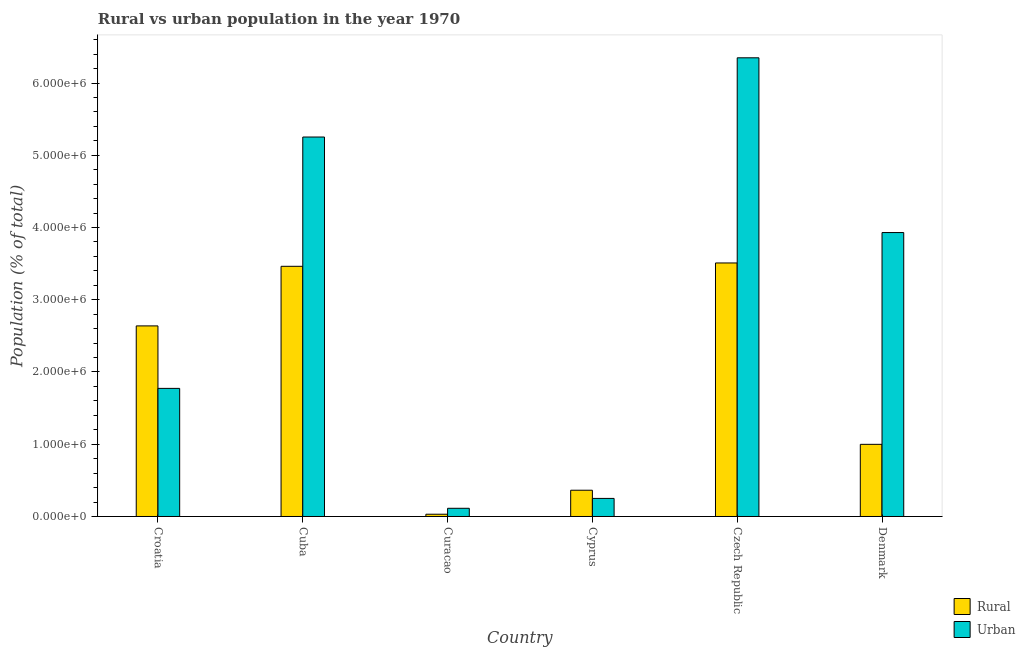How many different coloured bars are there?
Your answer should be very brief. 2. Are the number of bars on each tick of the X-axis equal?
Provide a short and direct response. Yes. How many bars are there on the 1st tick from the left?
Provide a succinct answer. 2. What is the label of the 5th group of bars from the left?
Provide a short and direct response. Czech Republic. What is the rural population density in Croatia?
Make the answer very short. 2.64e+06. Across all countries, what is the maximum rural population density?
Your answer should be compact. 3.51e+06. Across all countries, what is the minimum rural population density?
Keep it short and to the point. 3.12e+04. In which country was the rural population density maximum?
Give a very brief answer. Czech Republic. In which country was the urban population density minimum?
Provide a short and direct response. Curacao. What is the total urban population density in the graph?
Your response must be concise. 1.77e+07. What is the difference between the rural population density in Cyprus and that in Czech Republic?
Provide a succinct answer. -3.15e+06. What is the difference between the rural population density in Cyprus and the urban population density in Curacao?
Make the answer very short. 2.50e+05. What is the average urban population density per country?
Ensure brevity in your answer.  2.94e+06. What is the difference between the urban population density and rural population density in Denmark?
Offer a very short reply. 2.93e+06. What is the ratio of the urban population density in Croatia to that in Denmark?
Your answer should be compact. 0.45. Is the urban population density in Cuba less than that in Denmark?
Ensure brevity in your answer.  No. What is the difference between the highest and the second highest rural population density?
Your response must be concise. 4.64e+04. What is the difference between the highest and the lowest rural population density?
Provide a succinct answer. 3.48e+06. In how many countries, is the urban population density greater than the average urban population density taken over all countries?
Your response must be concise. 3. Is the sum of the rural population density in Curacao and Cyprus greater than the maximum urban population density across all countries?
Provide a succinct answer. No. What does the 1st bar from the left in Denmark represents?
Provide a succinct answer. Rural. What does the 1st bar from the right in Denmark represents?
Provide a short and direct response. Urban. How many bars are there?
Your answer should be very brief. 12. Are all the bars in the graph horizontal?
Keep it short and to the point. No. What is the difference between two consecutive major ticks on the Y-axis?
Make the answer very short. 1.00e+06. Are the values on the major ticks of Y-axis written in scientific E-notation?
Your response must be concise. Yes. Does the graph contain grids?
Offer a terse response. No. How many legend labels are there?
Offer a very short reply. 2. How are the legend labels stacked?
Ensure brevity in your answer.  Vertical. What is the title of the graph?
Your response must be concise. Rural vs urban population in the year 1970. What is the label or title of the X-axis?
Give a very brief answer. Country. What is the label or title of the Y-axis?
Your answer should be very brief. Population (% of total). What is the Population (% of total) of Rural in Croatia?
Your response must be concise. 2.64e+06. What is the Population (% of total) of Urban in Croatia?
Ensure brevity in your answer.  1.77e+06. What is the Population (% of total) of Rural in Cuba?
Provide a short and direct response. 3.46e+06. What is the Population (% of total) in Urban in Cuba?
Make the answer very short. 5.25e+06. What is the Population (% of total) in Rural in Curacao?
Offer a terse response. 3.12e+04. What is the Population (% of total) of Urban in Curacao?
Provide a succinct answer. 1.14e+05. What is the Population (% of total) of Rural in Cyprus?
Offer a terse response. 3.64e+05. What is the Population (% of total) of Urban in Cyprus?
Give a very brief answer. 2.50e+05. What is the Population (% of total) of Rural in Czech Republic?
Your answer should be very brief. 3.51e+06. What is the Population (% of total) of Urban in Czech Republic?
Your answer should be compact. 6.35e+06. What is the Population (% of total) of Rural in Denmark?
Your answer should be compact. 9.99e+05. What is the Population (% of total) of Urban in Denmark?
Ensure brevity in your answer.  3.93e+06. Across all countries, what is the maximum Population (% of total) in Rural?
Keep it short and to the point. 3.51e+06. Across all countries, what is the maximum Population (% of total) of Urban?
Offer a terse response. 6.35e+06. Across all countries, what is the minimum Population (% of total) of Rural?
Provide a succinct answer. 3.12e+04. Across all countries, what is the minimum Population (% of total) in Urban?
Provide a short and direct response. 1.14e+05. What is the total Population (% of total) of Rural in the graph?
Ensure brevity in your answer.  1.10e+07. What is the total Population (% of total) in Urban in the graph?
Your answer should be compact. 1.77e+07. What is the difference between the Population (% of total) in Rural in Croatia and that in Cuba?
Offer a terse response. -8.25e+05. What is the difference between the Population (% of total) in Urban in Croatia and that in Cuba?
Offer a very short reply. -3.48e+06. What is the difference between the Population (% of total) in Rural in Croatia and that in Curacao?
Give a very brief answer. 2.61e+06. What is the difference between the Population (% of total) of Urban in Croatia and that in Curacao?
Give a very brief answer. 1.66e+06. What is the difference between the Population (% of total) in Rural in Croatia and that in Cyprus?
Provide a short and direct response. 2.27e+06. What is the difference between the Population (% of total) in Urban in Croatia and that in Cyprus?
Ensure brevity in your answer.  1.52e+06. What is the difference between the Population (% of total) of Rural in Croatia and that in Czech Republic?
Keep it short and to the point. -8.71e+05. What is the difference between the Population (% of total) in Urban in Croatia and that in Czech Republic?
Give a very brief answer. -4.58e+06. What is the difference between the Population (% of total) in Rural in Croatia and that in Denmark?
Your answer should be compact. 1.64e+06. What is the difference between the Population (% of total) of Urban in Croatia and that in Denmark?
Ensure brevity in your answer.  -2.16e+06. What is the difference between the Population (% of total) in Rural in Cuba and that in Curacao?
Give a very brief answer. 3.43e+06. What is the difference between the Population (% of total) of Urban in Cuba and that in Curacao?
Offer a very short reply. 5.14e+06. What is the difference between the Population (% of total) in Rural in Cuba and that in Cyprus?
Make the answer very short. 3.10e+06. What is the difference between the Population (% of total) in Urban in Cuba and that in Cyprus?
Offer a very short reply. 5.00e+06. What is the difference between the Population (% of total) of Rural in Cuba and that in Czech Republic?
Give a very brief answer. -4.64e+04. What is the difference between the Population (% of total) in Urban in Cuba and that in Czech Republic?
Offer a very short reply. -1.10e+06. What is the difference between the Population (% of total) of Rural in Cuba and that in Denmark?
Offer a very short reply. 2.46e+06. What is the difference between the Population (% of total) of Urban in Cuba and that in Denmark?
Ensure brevity in your answer.  1.32e+06. What is the difference between the Population (% of total) in Rural in Curacao and that in Cyprus?
Your answer should be very brief. -3.32e+05. What is the difference between the Population (% of total) in Urban in Curacao and that in Cyprus?
Your response must be concise. -1.37e+05. What is the difference between the Population (% of total) of Rural in Curacao and that in Czech Republic?
Provide a succinct answer. -3.48e+06. What is the difference between the Population (% of total) in Urban in Curacao and that in Czech Republic?
Ensure brevity in your answer.  -6.24e+06. What is the difference between the Population (% of total) of Rural in Curacao and that in Denmark?
Give a very brief answer. -9.68e+05. What is the difference between the Population (% of total) in Urban in Curacao and that in Denmark?
Ensure brevity in your answer.  -3.82e+06. What is the difference between the Population (% of total) in Rural in Cyprus and that in Czech Republic?
Give a very brief answer. -3.15e+06. What is the difference between the Population (% of total) of Urban in Cyprus and that in Czech Republic?
Your answer should be very brief. -6.10e+06. What is the difference between the Population (% of total) of Rural in Cyprus and that in Denmark?
Offer a terse response. -6.35e+05. What is the difference between the Population (% of total) in Urban in Cyprus and that in Denmark?
Make the answer very short. -3.68e+06. What is the difference between the Population (% of total) in Rural in Czech Republic and that in Denmark?
Provide a short and direct response. 2.51e+06. What is the difference between the Population (% of total) of Urban in Czech Republic and that in Denmark?
Your answer should be compact. 2.42e+06. What is the difference between the Population (% of total) in Rural in Croatia and the Population (% of total) in Urban in Cuba?
Keep it short and to the point. -2.61e+06. What is the difference between the Population (% of total) of Rural in Croatia and the Population (% of total) of Urban in Curacao?
Ensure brevity in your answer.  2.52e+06. What is the difference between the Population (% of total) in Rural in Croatia and the Population (% of total) in Urban in Cyprus?
Make the answer very short. 2.39e+06. What is the difference between the Population (% of total) in Rural in Croatia and the Population (% of total) in Urban in Czech Republic?
Your answer should be very brief. -3.71e+06. What is the difference between the Population (% of total) of Rural in Croatia and the Population (% of total) of Urban in Denmark?
Your answer should be compact. -1.29e+06. What is the difference between the Population (% of total) in Rural in Cuba and the Population (% of total) in Urban in Curacao?
Keep it short and to the point. 3.35e+06. What is the difference between the Population (% of total) in Rural in Cuba and the Population (% of total) in Urban in Cyprus?
Keep it short and to the point. 3.21e+06. What is the difference between the Population (% of total) of Rural in Cuba and the Population (% of total) of Urban in Czech Republic?
Offer a very short reply. -2.89e+06. What is the difference between the Population (% of total) of Rural in Cuba and the Population (% of total) of Urban in Denmark?
Your response must be concise. -4.67e+05. What is the difference between the Population (% of total) in Rural in Curacao and the Population (% of total) in Urban in Cyprus?
Provide a short and direct response. -2.19e+05. What is the difference between the Population (% of total) in Rural in Curacao and the Population (% of total) in Urban in Czech Republic?
Your answer should be compact. -6.32e+06. What is the difference between the Population (% of total) of Rural in Curacao and the Population (% of total) of Urban in Denmark?
Give a very brief answer. -3.90e+06. What is the difference between the Population (% of total) in Rural in Cyprus and the Population (% of total) in Urban in Czech Republic?
Offer a terse response. -5.99e+06. What is the difference between the Population (% of total) of Rural in Cyprus and the Population (% of total) of Urban in Denmark?
Your response must be concise. -3.57e+06. What is the difference between the Population (% of total) in Rural in Czech Republic and the Population (% of total) in Urban in Denmark?
Your answer should be very brief. -4.21e+05. What is the average Population (% of total) of Rural per country?
Give a very brief answer. 1.83e+06. What is the average Population (% of total) in Urban per country?
Your response must be concise. 2.94e+06. What is the difference between the Population (% of total) of Rural and Population (% of total) of Urban in Croatia?
Your response must be concise. 8.65e+05. What is the difference between the Population (% of total) in Rural and Population (% of total) in Urban in Cuba?
Offer a very short reply. -1.79e+06. What is the difference between the Population (% of total) in Rural and Population (% of total) in Urban in Curacao?
Offer a terse response. -8.24e+04. What is the difference between the Population (% of total) of Rural and Population (% of total) of Urban in Cyprus?
Provide a short and direct response. 1.13e+05. What is the difference between the Population (% of total) in Rural and Population (% of total) in Urban in Czech Republic?
Ensure brevity in your answer.  -2.84e+06. What is the difference between the Population (% of total) in Rural and Population (% of total) in Urban in Denmark?
Give a very brief answer. -2.93e+06. What is the ratio of the Population (% of total) of Rural in Croatia to that in Cuba?
Provide a succinct answer. 0.76. What is the ratio of the Population (% of total) of Urban in Croatia to that in Cuba?
Ensure brevity in your answer.  0.34. What is the ratio of the Population (% of total) of Rural in Croatia to that in Curacao?
Offer a terse response. 84.57. What is the ratio of the Population (% of total) of Urban in Croatia to that in Curacao?
Ensure brevity in your answer.  15.62. What is the ratio of the Population (% of total) of Rural in Croatia to that in Cyprus?
Ensure brevity in your answer.  7.26. What is the ratio of the Population (% of total) in Urban in Croatia to that in Cyprus?
Make the answer very short. 7.09. What is the ratio of the Population (% of total) in Rural in Croatia to that in Czech Republic?
Make the answer very short. 0.75. What is the ratio of the Population (% of total) of Urban in Croatia to that in Czech Republic?
Your response must be concise. 0.28. What is the ratio of the Population (% of total) of Rural in Croatia to that in Denmark?
Offer a very short reply. 2.64. What is the ratio of the Population (% of total) of Urban in Croatia to that in Denmark?
Your answer should be very brief. 0.45. What is the ratio of the Population (% of total) of Rural in Cuba to that in Curacao?
Offer a terse response. 111.01. What is the ratio of the Population (% of total) in Urban in Cuba to that in Curacao?
Offer a terse response. 46.26. What is the ratio of the Population (% of total) in Rural in Cuba to that in Cyprus?
Keep it short and to the point. 9.53. What is the ratio of the Population (% of total) in Urban in Cuba to that in Cyprus?
Keep it short and to the point. 21. What is the ratio of the Population (% of total) of Rural in Cuba to that in Czech Republic?
Offer a very short reply. 0.99. What is the ratio of the Population (% of total) of Urban in Cuba to that in Czech Republic?
Provide a short and direct response. 0.83. What is the ratio of the Population (% of total) in Rural in Cuba to that in Denmark?
Keep it short and to the point. 3.47. What is the ratio of the Population (% of total) in Urban in Cuba to that in Denmark?
Your answer should be compact. 1.34. What is the ratio of the Population (% of total) of Rural in Curacao to that in Cyprus?
Give a very brief answer. 0.09. What is the ratio of the Population (% of total) of Urban in Curacao to that in Cyprus?
Your response must be concise. 0.45. What is the ratio of the Population (% of total) in Rural in Curacao to that in Czech Republic?
Make the answer very short. 0.01. What is the ratio of the Population (% of total) in Urban in Curacao to that in Czech Republic?
Offer a very short reply. 0.02. What is the ratio of the Population (% of total) in Rural in Curacao to that in Denmark?
Your response must be concise. 0.03. What is the ratio of the Population (% of total) in Urban in Curacao to that in Denmark?
Make the answer very short. 0.03. What is the ratio of the Population (% of total) of Rural in Cyprus to that in Czech Republic?
Provide a short and direct response. 0.1. What is the ratio of the Population (% of total) of Urban in Cyprus to that in Czech Republic?
Your answer should be compact. 0.04. What is the ratio of the Population (% of total) of Rural in Cyprus to that in Denmark?
Keep it short and to the point. 0.36. What is the ratio of the Population (% of total) in Urban in Cyprus to that in Denmark?
Provide a succinct answer. 0.06. What is the ratio of the Population (% of total) of Rural in Czech Republic to that in Denmark?
Your response must be concise. 3.51. What is the ratio of the Population (% of total) in Urban in Czech Republic to that in Denmark?
Provide a succinct answer. 1.62. What is the difference between the highest and the second highest Population (% of total) in Rural?
Your response must be concise. 4.64e+04. What is the difference between the highest and the second highest Population (% of total) in Urban?
Your response must be concise. 1.10e+06. What is the difference between the highest and the lowest Population (% of total) of Rural?
Ensure brevity in your answer.  3.48e+06. What is the difference between the highest and the lowest Population (% of total) in Urban?
Your answer should be compact. 6.24e+06. 